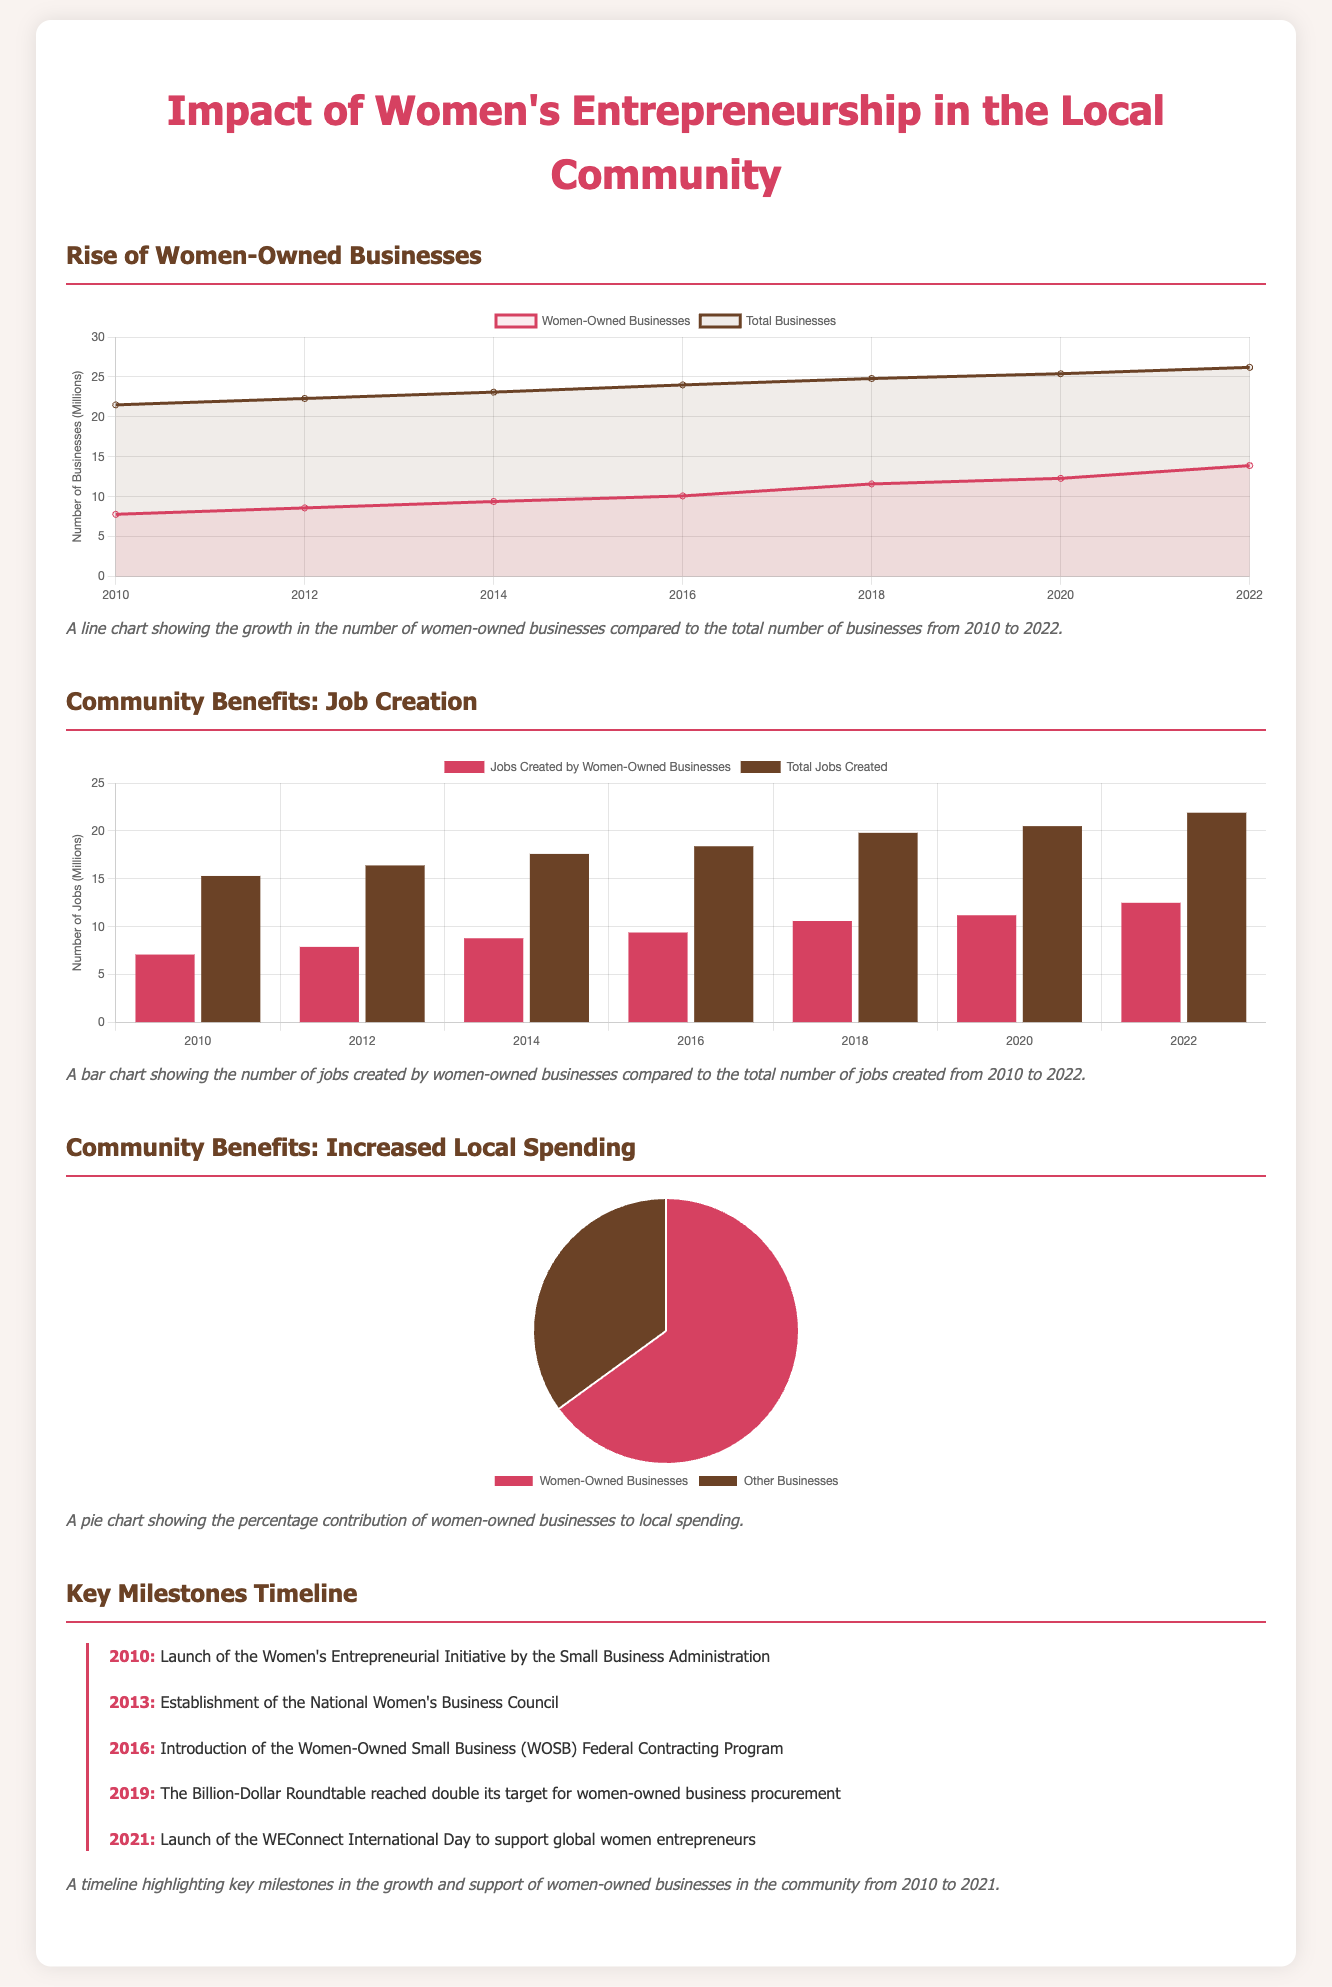What is the growth rate of women-owned businesses in 2022? The growth of women-owned businesses in 2022 is shown in the line chart, which indicates a value of 13.9 million.
Answer: 13.9 million What year was the Women-Owned Small Business Federal Contracting Program introduced? The document provides a timeline highlighting key milestones, identifying 2016 as the year of introduction for the WOSB Federal Contracting Program.
Answer: 2016 What percentage of local spending comes from women-owned businesses? The pie chart outlines that women-owned businesses contribute 65% to local spending.
Answer: 65% How many jobs were created by women-owned businesses in 2018? According to the bar chart, the number of jobs created by women-owned businesses in 2018 is represented by the value of 10.6 million.
Answer: 10.6 million What is the total number of businesses in 2010? The line chart specifies the total number of businesses in 2010 as 21.5 million.
Answer: 21.5 million Which milestone was reached in 2019? The timeline indicates that in 2019, the Billion-Dollar Roundtable reached double its target for women-owned business procurement.
Answer: Reached double its target How many total jobs were created in 2022? The bar chart shows that the total number of jobs created in 2022 is 21.9 million.
Answer: 21.9 million What is the purpose of the Women's Entrepreneurial Initiative launched in 2010? The timeline notes that it was launched by the Small Business Administration to support women entrepreneurs, indicating its goal.
Answer: Support women entrepreneurs What is the color representing jobs created by women-owned businesses in the bar chart? The document describes the color used for jobs created by women-owned businesses as '#d64161'.
Answer: '#d64161' 